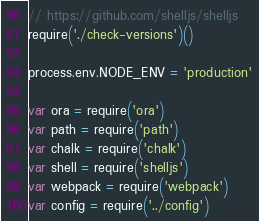<code> <loc_0><loc_0><loc_500><loc_500><_JavaScript_>// https://github.com/shelljs/shelljs
require('./check-versions')()

process.env.NODE_ENV = 'production'

var ora = require('ora')
var path = require('path')
var chalk = require('chalk')
var shell = require('shelljs')
var webpack = require('webpack')
var config = require('../config')</code> 